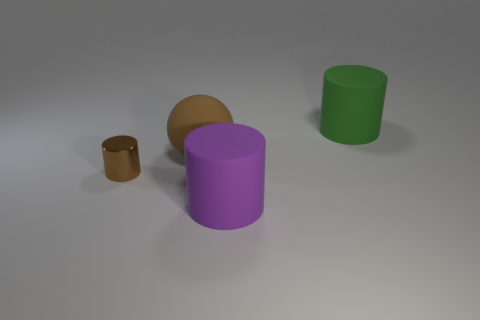There is a metallic object that is the same color as the ball; what is its shape?
Provide a short and direct response. Cylinder. How many objects are rubber objects right of the large purple matte cylinder or small purple rubber objects?
Make the answer very short. 1. Is the size of the metal cylinder the same as the purple matte object?
Offer a terse response. No. The big rubber cylinder behind the tiny shiny cylinder is what color?
Give a very brief answer. Green. What is the size of the purple cylinder that is made of the same material as the brown sphere?
Keep it short and to the point. Large. There is a brown cylinder; does it have the same size as the matte cylinder that is in front of the brown rubber sphere?
Your answer should be very brief. No. There is a big cylinder in front of the small cylinder; what material is it?
Ensure brevity in your answer.  Rubber. What number of small things are to the right of the matte cylinder that is left of the big green cylinder?
Provide a short and direct response. 0. Is there a big brown thing of the same shape as the small metal thing?
Ensure brevity in your answer.  No. Does the brown thing on the left side of the big brown rubber thing have the same size as the matte cylinder behind the brown rubber thing?
Provide a short and direct response. No. 